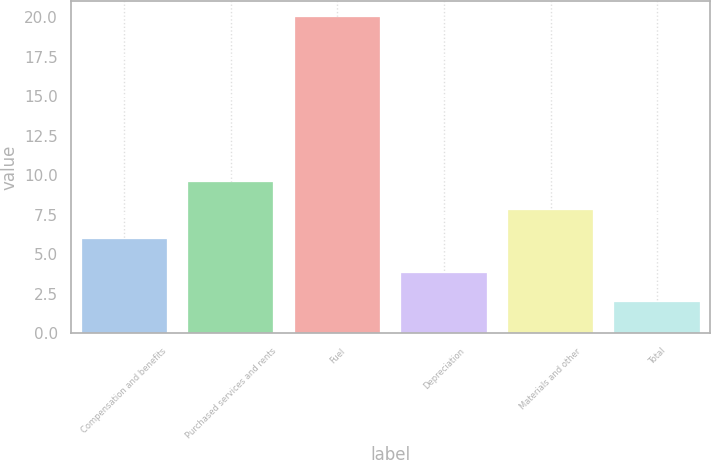<chart> <loc_0><loc_0><loc_500><loc_500><bar_chart><fcel>Compensation and benefits<fcel>Purchased services and rents<fcel>Fuel<fcel>Depreciation<fcel>Materials and other<fcel>Total<nl><fcel>6<fcel>9.6<fcel>20<fcel>3.8<fcel>7.8<fcel>2<nl></chart> 